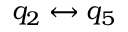Convert formula to latex. <formula><loc_0><loc_0><loc_500><loc_500>q _ { 2 } \leftrightarrow q _ { 5 }</formula> 